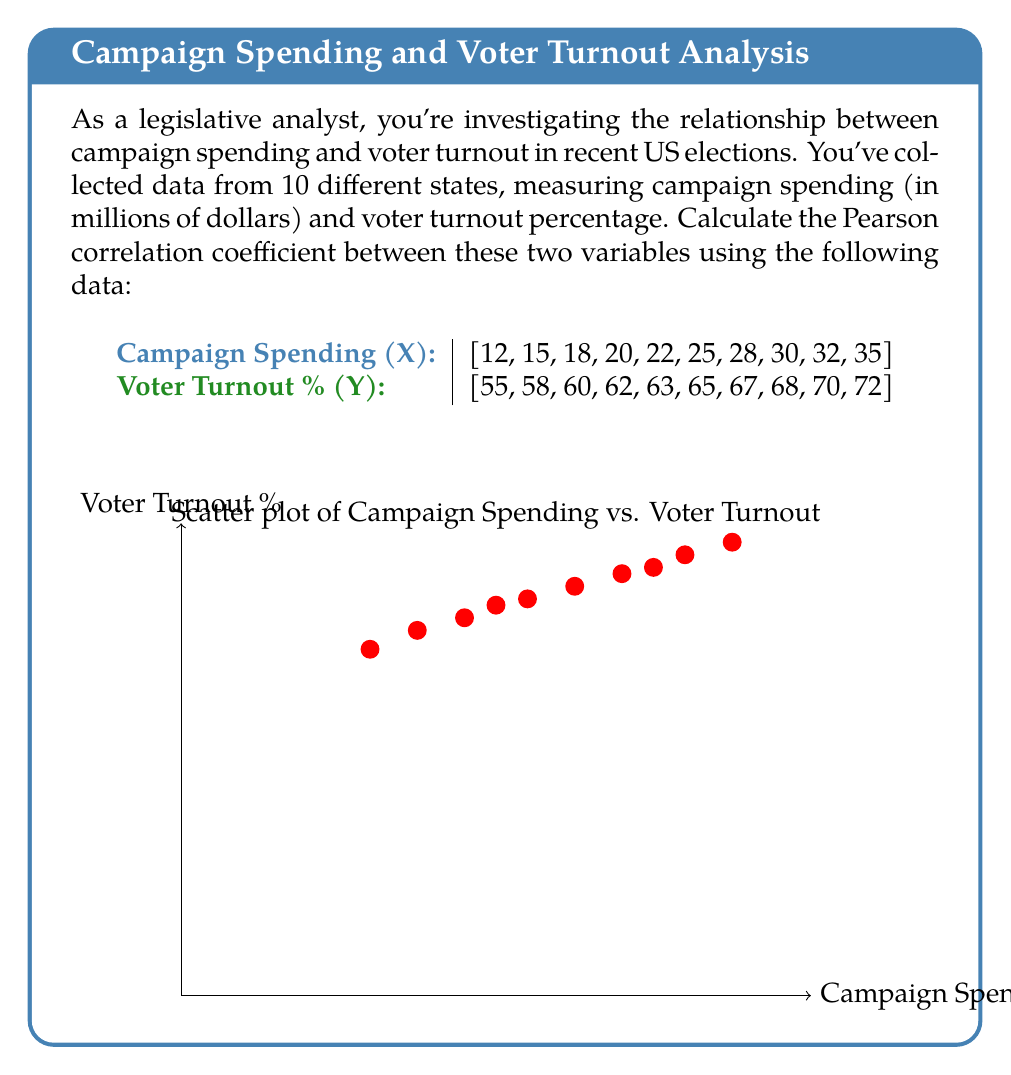Can you solve this math problem? To calculate the Pearson correlation coefficient (r), we'll use the formula:

$$ r = \frac{\sum_{i=1}^{n} (x_i - \bar{x})(y_i - \bar{y})}{\sqrt{\sum_{i=1}^{n} (x_i - \bar{x})^2 \sum_{i=1}^{n} (y_i - \bar{y})^2}} $$

Step 1: Calculate the means $\bar{x}$ and $\bar{y}$
$\bar{x} = \frac{12 + 15 + 18 + 20 + 22 + 25 + 28 + 30 + 32 + 35}{10} = 23.7$
$\bar{y} = \frac{55 + 58 + 60 + 62 + 63 + 65 + 67 + 68 + 70 + 72}{10} = 64$

Step 2: Calculate $(x_i - \bar{x})$, $(y_i - \bar{y})$, $(x_i - \bar{x})^2$, $(y_i - \bar{y})^2$, and $(x_i - \bar{x})(y_i - \bar{y})$ for each pair

Step 3: Sum up the calculated values
$\sum (x_i - \bar{x})(y_i - \bar{y}) = 306.5$
$\sum (x_i - \bar{x})^2 = 470.1$
$\sum (y_i - \bar{y})^2 = 262$

Step 4: Apply the formula
$$ r = \frac{306.5}{\sqrt{470.1 \times 262}} = \frac{306.5}{\sqrt{123166.2}} = \frac{306.5}{350.95} $$

Step 5: Calculate the final result
$r \approx 0.8733$
Answer: $r \approx 0.8733$ 